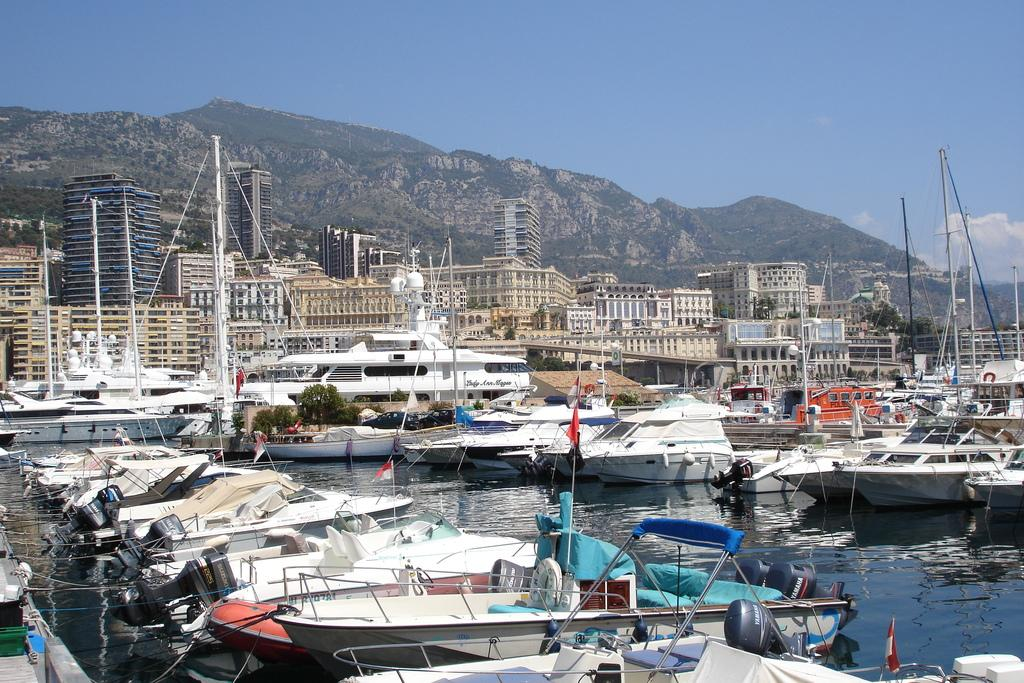What is on the water surface in the image? There are ships on the water surface in the image. What can be seen behind the ships? There are buildings behind the ships. What is visible in the far background of the image? There are mountains visible in the background of the image. Where is the donkey grazing in the image? There is no donkey present in the image. What type of thread is being used to sew the garden in the image? There is no thread or garden present in the image. 